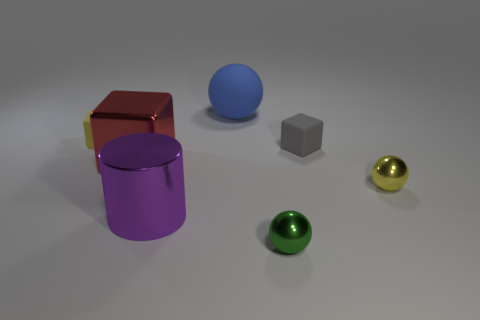Are there an equal number of matte balls to the right of the rubber ball and small green shiny spheres in front of the tiny green metallic object?
Make the answer very short. Yes. Are there any tiny balls made of the same material as the blue thing?
Ensure brevity in your answer.  No. Is the tiny gray block made of the same material as the large blue thing?
Your response must be concise. Yes. How many purple things are either big shiny cubes or cylinders?
Offer a very short reply. 1. Is the number of small yellow rubber cubes that are to the right of the small yellow sphere greater than the number of big purple shiny cylinders?
Your response must be concise. No. Are there any shiny spheres of the same color as the metallic cylinder?
Ensure brevity in your answer.  No. The green object has what size?
Provide a succinct answer. Small. Does the big block have the same color as the cylinder?
Provide a short and direct response. No. What number of things are either big red shiny cubes or small yellow things right of the gray rubber thing?
Your response must be concise. 2. What number of big metallic things are in front of the yellow object that is right of the yellow thing that is behind the metallic block?
Offer a very short reply. 1. 